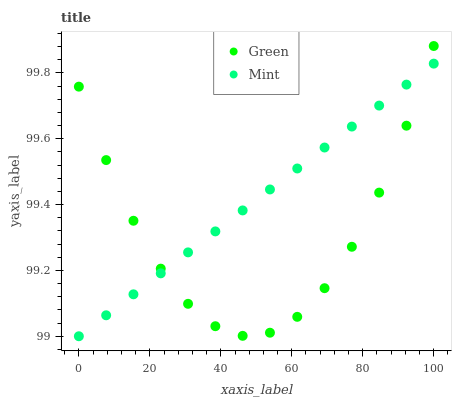Does Green have the minimum area under the curve?
Answer yes or no. Yes. Does Mint have the maximum area under the curve?
Answer yes or no. Yes. Does Green have the maximum area under the curve?
Answer yes or no. No. Is Mint the smoothest?
Answer yes or no. Yes. Is Green the roughest?
Answer yes or no. Yes. Is Green the smoothest?
Answer yes or no. No. Does Mint have the lowest value?
Answer yes or no. Yes. Does Green have the lowest value?
Answer yes or no. No. Does Green have the highest value?
Answer yes or no. Yes. Does Green intersect Mint?
Answer yes or no. Yes. Is Green less than Mint?
Answer yes or no. No. Is Green greater than Mint?
Answer yes or no. No. 